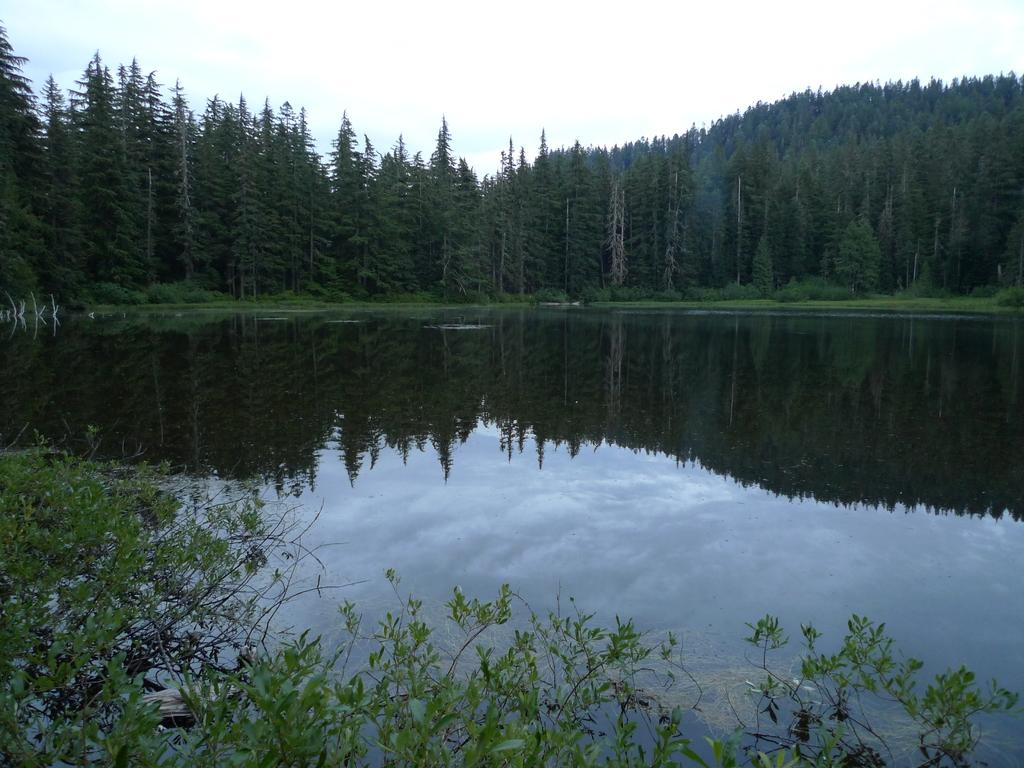What is the primary element in the image? The image contains water. What types of vegetation can be seen in the image? There are plants and trees in the image. What part of the natural environment is visible in the background of the image? The sky is visible in the background of the image. What type of stocking is hanging from the tree in the image? There is no stocking hanging from the tree in the image; it only contains water, plants, trees, and the sky. 